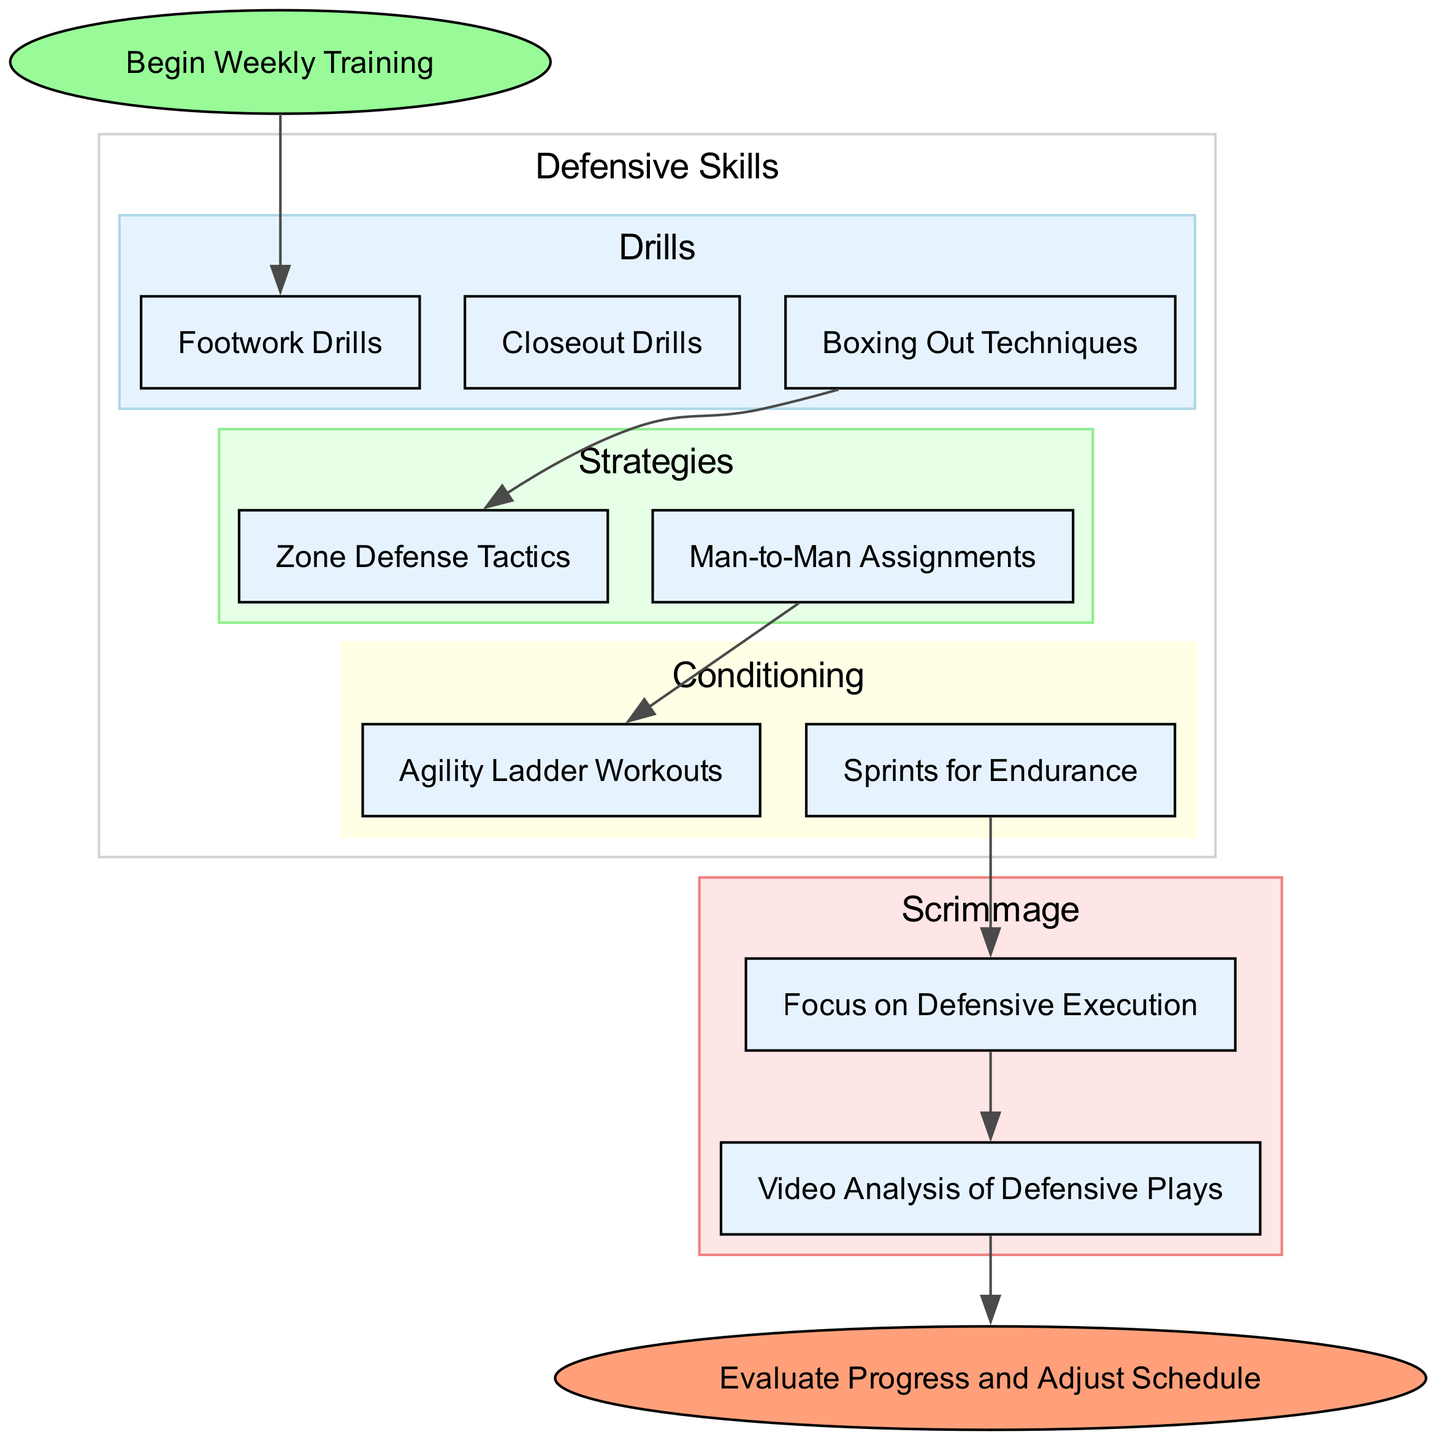What is the first step in the training schedule? The first step in the training schedule is labeled as "Begin Weekly Training," which is indicated at the top of the flow chart.
Answer: Begin Weekly Training How many drills are listed under Defensive Skills? There are three drills listed under Defensive Skills: Footwork Drills, Closeout Drills, and Boxing Out Techniques. Counting these gives a total of three drills.
Answer: 3 What are the two types of strategies mentioned? The two types of strategies mentioned are "Zone Defense Tactics" and "Man-to-Man Assignments" found within the Strategies section.
Answer: Zone Defense Tactics, Man-to-Man Assignments Which conditioning exercise directly leads to the scrimmage? The conditioning exercise "Sprints for Endurance" leads to "Organized Scrimmage," as shown in the flow from the conditioning to the scrimmage section.
Answer: Sprints for Endurance What feedback method is used after the scrimmage? The feedback method used after the scrimmage is "Video Analysis of Defensive Plays," which indicates how the team reflects on their performance.
Answer: Video Analysis of Defensive Plays Which drill connects to Zone Defense Tactics? The drill "Boxing Out Techniques" connects to "Zone Defense Tactics," as shown by the edge linking these two nodes in the flow chart.
Answer: Boxing Out Techniques In what section do the Agility Ladder Workouts appear? The "Agility Ladder Workouts" appear in the Conditioning section, which is identified within the Defensive Skills part of the flow chart.
Answer: Conditioning What is the final step in the training schedule? The final step in the training schedule is "Evaluate Progress and Adjust Schedule," which is indicated at the end of the flow chart.
Answer: Evaluate Progress and Adjust Schedule How many sections are in the Defensive Skills category? There are three sections in the Defensive Skills category: Drills, Strategies, and Conditioning, making a total of three sections.
Answer: 3 